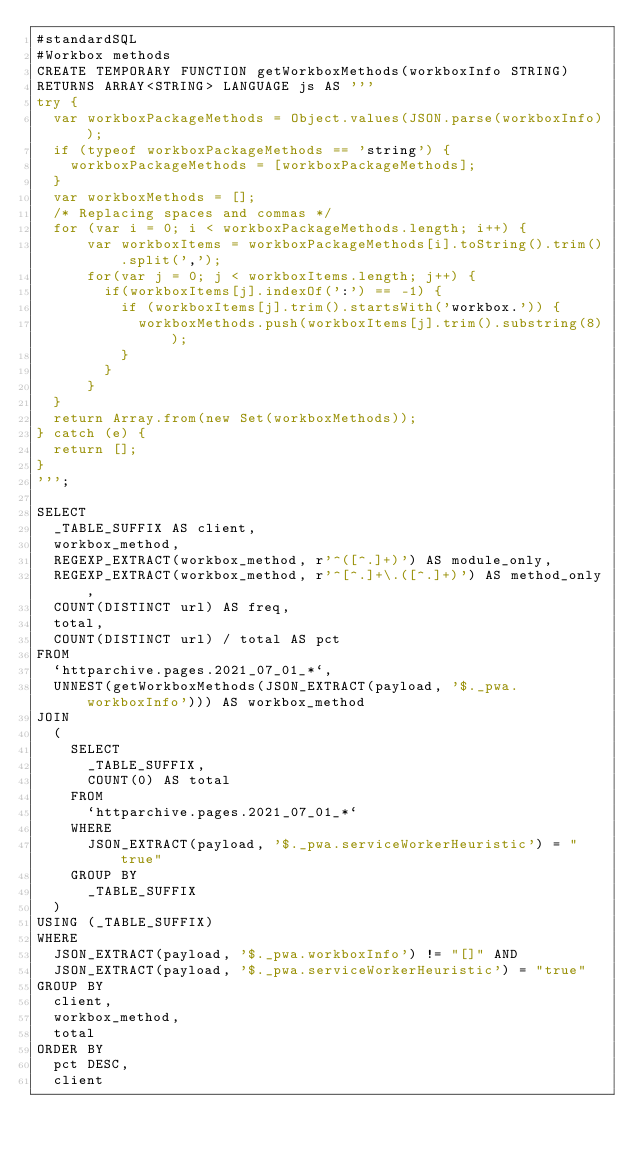Convert code to text. <code><loc_0><loc_0><loc_500><loc_500><_SQL_>#standardSQL
#Workbox methods
CREATE TEMPORARY FUNCTION getWorkboxMethods(workboxInfo STRING)
RETURNS ARRAY<STRING> LANGUAGE js AS '''
try {
  var workboxPackageMethods = Object.values(JSON.parse(workboxInfo));
  if (typeof workboxPackageMethods == 'string') {
    workboxPackageMethods = [workboxPackageMethods];
  }
  var workboxMethods = [];
  /* Replacing spaces and commas */
  for (var i = 0; i < workboxPackageMethods.length; i++) {
      var workboxItems = workboxPackageMethods[i].toString().trim().split(',');
      for(var j = 0; j < workboxItems.length; j++) {
        if(workboxItems[j].indexOf(':') == -1) {
          if (workboxItems[j].trim().startsWith('workbox.')) {
            workboxMethods.push(workboxItems[j].trim().substring(8));
          }
        }
      }
  }
  return Array.from(new Set(workboxMethods));
} catch (e) {
  return [];
}
''';

SELECT
  _TABLE_SUFFIX AS client,
  workbox_method,
  REGEXP_EXTRACT(workbox_method, r'^([^.]+)') AS module_only,
  REGEXP_EXTRACT(workbox_method, r'^[^.]+\.([^.]+)') AS method_only,
  COUNT(DISTINCT url) AS freq,
  total,
  COUNT(DISTINCT url) / total AS pct
FROM
  `httparchive.pages.2021_07_01_*`,
  UNNEST(getWorkboxMethods(JSON_EXTRACT(payload, '$._pwa.workboxInfo'))) AS workbox_method
JOIN
  (
    SELECT
      _TABLE_SUFFIX,
      COUNT(0) AS total
    FROM
      `httparchive.pages.2021_07_01_*`
    WHERE
      JSON_EXTRACT(payload, '$._pwa.serviceWorkerHeuristic') = "true"
    GROUP BY
      _TABLE_SUFFIX
  )
USING (_TABLE_SUFFIX)
WHERE
  JSON_EXTRACT(payload, '$._pwa.workboxInfo') != "[]" AND
  JSON_EXTRACT(payload, '$._pwa.serviceWorkerHeuristic') = "true"
GROUP BY
  client,
  workbox_method,
  total
ORDER BY
  pct DESC,
  client
</code> 